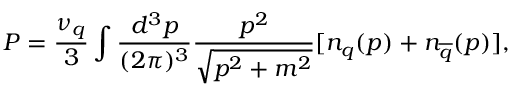<formula> <loc_0><loc_0><loc_500><loc_500>P = \frac { \nu _ { q } } { 3 } \int \frac { d ^ { 3 } p } { ( 2 \pi ) ^ { 3 } } \frac { p ^ { 2 } } { \sqrt { p ^ { 2 } + m ^ { 2 } } } [ n _ { q } ( p ) + n _ { \overline { q } } ( p ) ] ,</formula> 